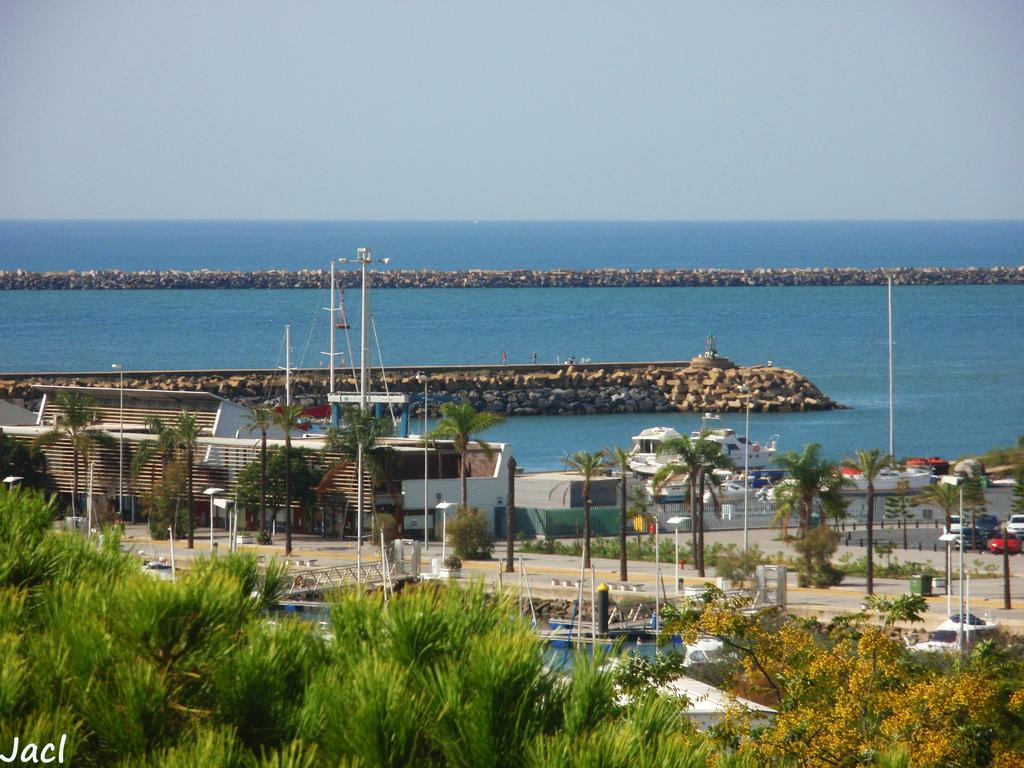What type of natural elements can be seen in the image? There are trees and plants visible in the image. What man-made objects can be seen in the image? There are vehicles and boats visible in the image. What type of structure is present in the image? There is a wall in the image. What materials are present in the image? Wooden sticks are visible in the image. What is visible in the background of the image? The background of the image includes the ocean, rocks, and the sky. What grade does the teacher give to the twist in the image? There is no twist present in the image, nor is there a teacher or any indication of a grading system. 